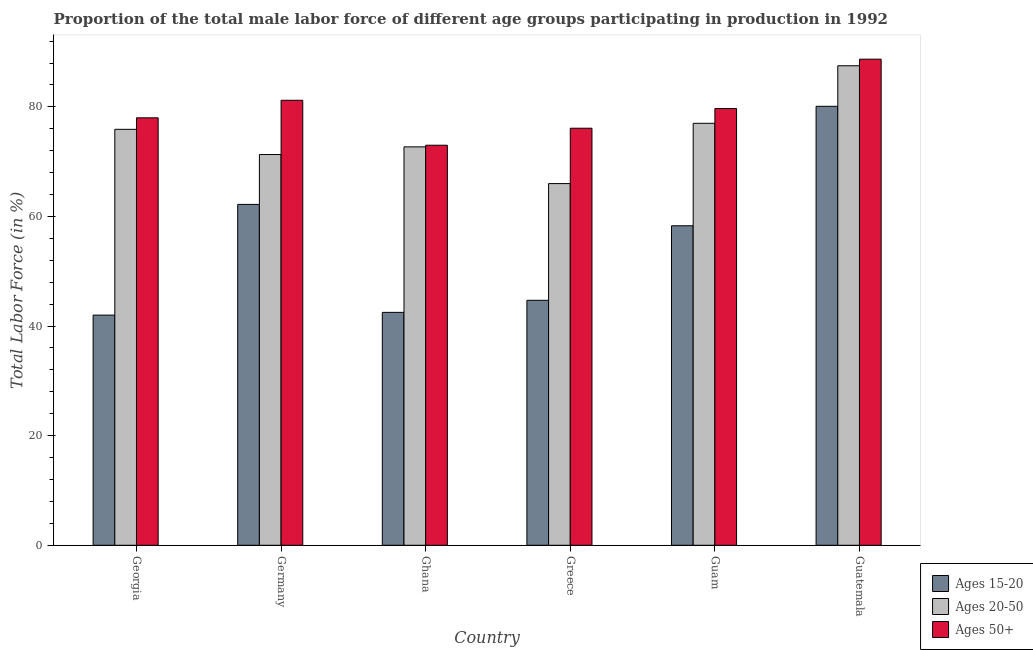How many different coloured bars are there?
Provide a succinct answer. 3. How many groups of bars are there?
Keep it short and to the point. 6. Are the number of bars per tick equal to the number of legend labels?
Provide a succinct answer. Yes. How many bars are there on the 4th tick from the left?
Offer a very short reply. 3. How many bars are there on the 6th tick from the right?
Provide a short and direct response. 3. In how many cases, is the number of bars for a given country not equal to the number of legend labels?
Provide a succinct answer. 0. What is the percentage of male labor force within the age group 15-20 in Guatemala?
Ensure brevity in your answer.  80.1. Across all countries, what is the maximum percentage of male labor force within the age group 20-50?
Your answer should be very brief. 87.5. In which country was the percentage of male labor force within the age group 15-20 maximum?
Provide a short and direct response. Guatemala. In which country was the percentage of male labor force above age 50 minimum?
Offer a terse response. Ghana. What is the total percentage of male labor force above age 50 in the graph?
Your response must be concise. 476.7. What is the difference between the percentage of male labor force within the age group 20-50 in Germany and that in Greece?
Make the answer very short. 5.3. What is the difference between the percentage of male labor force within the age group 20-50 in Greece and the percentage of male labor force above age 50 in Guam?
Offer a very short reply. -13.7. What is the average percentage of male labor force above age 50 per country?
Keep it short and to the point. 79.45. What is the difference between the percentage of male labor force above age 50 and percentage of male labor force within the age group 15-20 in Guatemala?
Offer a terse response. 8.6. What is the ratio of the percentage of male labor force above age 50 in Ghana to that in Guam?
Your answer should be compact. 0.92. Is the percentage of male labor force within the age group 20-50 in Ghana less than that in Guam?
Offer a very short reply. Yes. What is the difference between the highest and the second highest percentage of male labor force within the age group 15-20?
Provide a short and direct response. 17.9. In how many countries, is the percentage of male labor force within the age group 20-50 greater than the average percentage of male labor force within the age group 20-50 taken over all countries?
Your answer should be very brief. 3. Is the sum of the percentage of male labor force within the age group 15-20 in Germany and Greece greater than the maximum percentage of male labor force within the age group 20-50 across all countries?
Offer a very short reply. Yes. What does the 1st bar from the left in Ghana represents?
Your answer should be very brief. Ages 15-20. What does the 3rd bar from the right in Guatemala represents?
Offer a very short reply. Ages 15-20. How many bars are there?
Keep it short and to the point. 18. Are all the bars in the graph horizontal?
Your answer should be compact. No. Are the values on the major ticks of Y-axis written in scientific E-notation?
Keep it short and to the point. No. Does the graph contain any zero values?
Offer a very short reply. No. Does the graph contain grids?
Offer a terse response. No. Where does the legend appear in the graph?
Your answer should be very brief. Bottom right. How many legend labels are there?
Provide a succinct answer. 3. How are the legend labels stacked?
Provide a succinct answer. Vertical. What is the title of the graph?
Offer a very short reply. Proportion of the total male labor force of different age groups participating in production in 1992. What is the Total Labor Force (in %) of Ages 20-50 in Georgia?
Give a very brief answer. 75.9. What is the Total Labor Force (in %) in Ages 15-20 in Germany?
Provide a short and direct response. 62.2. What is the Total Labor Force (in %) of Ages 20-50 in Germany?
Provide a short and direct response. 71.3. What is the Total Labor Force (in %) in Ages 50+ in Germany?
Provide a succinct answer. 81.2. What is the Total Labor Force (in %) of Ages 15-20 in Ghana?
Provide a succinct answer. 42.5. What is the Total Labor Force (in %) in Ages 20-50 in Ghana?
Provide a succinct answer. 72.7. What is the Total Labor Force (in %) of Ages 15-20 in Greece?
Offer a terse response. 44.7. What is the Total Labor Force (in %) in Ages 20-50 in Greece?
Offer a terse response. 66. What is the Total Labor Force (in %) in Ages 50+ in Greece?
Offer a terse response. 76.1. What is the Total Labor Force (in %) of Ages 15-20 in Guam?
Your answer should be very brief. 58.3. What is the Total Labor Force (in %) of Ages 20-50 in Guam?
Ensure brevity in your answer.  77. What is the Total Labor Force (in %) in Ages 50+ in Guam?
Ensure brevity in your answer.  79.7. What is the Total Labor Force (in %) in Ages 15-20 in Guatemala?
Ensure brevity in your answer.  80.1. What is the Total Labor Force (in %) of Ages 20-50 in Guatemala?
Give a very brief answer. 87.5. What is the Total Labor Force (in %) in Ages 50+ in Guatemala?
Your answer should be compact. 88.7. Across all countries, what is the maximum Total Labor Force (in %) of Ages 15-20?
Ensure brevity in your answer.  80.1. Across all countries, what is the maximum Total Labor Force (in %) of Ages 20-50?
Your answer should be very brief. 87.5. Across all countries, what is the maximum Total Labor Force (in %) of Ages 50+?
Provide a succinct answer. 88.7. Across all countries, what is the minimum Total Labor Force (in %) in Ages 20-50?
Ensure brevity in your answer.  66. What is the total Total Labor Force (in %) in Ages 15-20 in the graph?
Your response must be concise. 329.8. What is the total Total Labor Force (in %) of Ages 20-50 in the graph?
Ensure brevity in your answer.  450.4. What is the total Total Labor Force (in %) in Ages 50+ in the graph?
Make the answer very short. 476.7. What is the difference between the Total Labor Force (in %) in Ages 15-20 in Georgia and that in Germany?
Offer a very short reply. -20.2. What is the difference between the Total Labor Force (in %) in Ages 20-50 in Georgia and that in Germany?
Give a very brief answer. 4.6. What is the difference between the Total Labor Force (in %) in Ages 50+ in Georgia and that in Germany?
Offer a terse response. -3.2. What is the difference between the Total Labor Force (in %) in Ages 15-20 in Georgia and that in Ghana?
Offer a terse response. -0.5. What is the difference between the Total Labor Force (in %) in Ages 15-20 in Georgia and that in Guam?
Provide a succinct answer. -16.3. What is the difference between the Total Labor Force (in %) of Ages 20-50 in Georgia and that in Guam?
Give a very brief answer. -1.1. What is the difference between the Total Labor Force (in %) of Ages 50+ in Georgia and that in Guam?
Provide a short and direct response. -1.7. What is the difference between the Total Labor Force (in %) of Ages 15-20 in Georgia and that in Guatemala?
Your answer should be very brief. -38.1. What is the difference between the Total Labor Force (in %) of Ages 20-50 in Georgia and that in Guatemala?
Offer a very short reply. -11.6. What is the difference between the Total Labor Force (in %) of Ages 50+ in Georgia and that in Guatemala?
Your answer should be very brief. -10.7. What is the difference between the Total Labor Force (in %) of Ages 15-20 in Germany and that in Ghana?
Offer a very short reply. 19.7. What is the difference between the Total Labor Force (in %) of Ages 20-50 in Germany and that in Ghana?
Your answer should be very brief. -1.4. What is the difference between the Total Labor Force (in %) in Ages 50+ in Germany and that in Ghana?
Ensure brevity in your answer.  8.2. What is the difference between the Total Labor Force (in %) in Ages 15-20 in Germany and that in Greece?
Your response must be concise. 17.5. What is the difference between the Total Labor Force (in %) of Ages 50+ in Germany and that in Greece?
Offer a terse response. 5.1. What is the difference between the Total Labor Force (in %) in Ages 15-20 in Germany and that in Guam?
Keep it short and to the point. 3.9. What is the difference between the Total Labor Force (in %) of Ages 50+ in Germany and that in Guam?
Provide a short and direct response. 1.5. What is the difference between the Total Labor Force (in %) in Ages 15-20 in Germany and that in Guatemala?
Give a very brief answer. -17.9. What is the difference between the Total Labor Force (in %) in Ages 20-50 in Germany and that in Guatemala?
Your answer should be compact. -16.2. What is the difference between the Total Labor Force (in %) in Ages 50+ in Germany and that in Guatemala?
Offer a very short reply. -7.5. What is the difference between the Total Labor Force (in %) of Ages 20-50 in Ghana and that in Greece?
Provide a short and direct response. 6.7. What is the difference between the Total Labor Force (in %) of Ages 15-20 in Ghana and that in Guam?
Give a very brief answer. -15.8. What is the difference between the Total Labor Force (in %) in Ages 15-20 in Ghana and that in Guatemala?
Make the answer very short. -37.6. What is the difference between the Total Labor Force (in %) in Ages 20-50 in Ghana and that in Guatemala?
Make the answer very short. -14.8. What is the difference between the Total Labor Force (in %) of Ages 50+ in Ghana and that in Guatemala?
Ensure brevity in your answer.  -15.7. What is the difference between the Total Labor Force (in %) in Ages 20-50 in Greece and that in Guam?
Your answer should be compact. -11. What is the difference between the Total Labor Force (in %) in Ages 15-20 in Greece and that in Guatemala?
Provide a succinct answer. -35.4. What is the difference between the Total Labor Force (in %) in Ages 20-50 in Greece and that in Guatemala?
Make the answer very short. -21.5. What is the difference between the Total Labor Force (in %) of Ages 15-20 in Guam and that in Guatemala?
Ensure brevity in your answer.  -21.8. What is the difference between the Total Labor Force (in %) of Ages 50+ in Guam and that in Guatemala?
Your answer should be compact. -9. What is the difference between the Total Labor Force (in %) in Ages 15-20 in Georgia and the Total Labor Force (in %) in Ages 20-50 in Germany?
Give a very brief answer. -29.3. What is the difference between the Total Labor Force (in %) in Ages 15-20 in Georgia and the Total Labor Force (in %) in Ages 50+ in Germany?
Provide a succinct answer. -39.2. What is the difference between the Total Labor Force (in %) in Ages 20-50 in Georgia and the Total Labor Force (in %) in Ages 50+ in Germany?
Give a very brief answer. -5.3. What is the difference between the Total Labor Force (in %) in Ages 15-20 in Georgia and the Total Labor Force (in %) in Ages 20-50 in Ghana?
Give a very brief answer. -30.7. What is the difference between the Total Labor Force (in %) of Ages 15-20 in Georgia and the Total Labor Force (in %) of Ages 50+ in Ghana?
Ensure brevity in your answer.  -31. What is the difference between the Total Labor Force (in %) in Ages 20-50 in Georgia and the Total Labor Force (in %) in Ages 50+ in Ghana?
Provide a succinct answer. 2.9. What is the difference between the Total Labor Force (in %) of Ages 15-20 in Georgia and the Total Labor Force (in %) of Ages 50+ in Greece?
Offer a terse response. -34.1. What is the difference between the Total Labor Force (in %) in Ages 15-20 in Georgia and the Total Labor Force (in %) in Ages 20-50 in Guam?
Give a very brief answer. -35. What is the difference between the Total Labor Force (in %) in Ages 15-20 in Georgia and the Total Labor Force (in %) in Ages 50+ in Guam?
Make the answer very short. -37.7. What is the difference between the Total Labor Force (in %) of Ages 15-20 in Georgia and the Total Labor Force (in %) of Ages 20-50 in Guatemala?
Your response must be concise. -45.5. What is the difference between the Total Labor Force (in %) of Ages 15-20 in Georgia and the Total Labor Force (in %) of Ages 50+ in Guatemala?
Keep it short and to the point. -46.7. What is the difference between the Total Labor Force (in %) in Ages 20-50 in Germany and the Total Labor Force (in %) in Ages 50+ in Ghana?
Ensure brevity in your answer.  -1.7. What is the difference between the Total Labor Force (in %) of Ages 20-50 in Germany and the Total Labor Force (in %) of Ages 50+ in Greece?
Ensure brevity in your answer.  -4.8. What is the difference between the Total Labor Force (in %) in Ages 15-20 in Germany and the Total Labor Force (in %) in Ages 20-50 in Guam?
Give a very brief answer. -14.8. What is the difference between the Total Labor Force (in %) in Ages 15-20 in Germany and the Total Labor Force (in %) in Ages 50+ in Guam?
Offer a terse response. -17.5. What is the difference between the Total Labor Force (in %) of Ages 15-20 in Germany and the Total Labor Force (in %) of Ages 20-50 in Guatemala?
Your answer should be compact. -25.3. What is the difference between the Total Labor Force (in %) of Ages 15-20 in Germany and the Total Labor Force (in %) of Ages 50+ in Guatemala?
Make the answer very short. -26.5. What is the difference between the Total Labor Force (in %) of Ages 20-50 in Germany and the Total Labor Force (in %) of Ages 50+ in Guatemala?
Keep it short and to the point. -17.4. What is the difference between the Total Labor Force (in %) in Ages 15-20 in Ghana and the Total Labor Force (in %) in Ages 20-50 in Greece?
Provide a short and direct response. -23.5. What is the difference between the Total Labor Force (in %) of Ages 15-20 in Ghana and the Total Labor Force (in %) of Ages 50+ in Greece?
Offer a terse response. -33.6. What is the difference between the Total Labor Force (in %) of Ages 15-20 in Ghana and the Total Labor Force (in %) of Ages 20-50 in Guam?
Ensure brevity in your answer.  -34.5. What is the difference between the Total Labor Force (in %) of Ages 15-20 in Ghana and the Total Labor Force (in %) of Ages 50+ in Guam?
Make the answer very short. -37.2. What is the difference between the Total Labor Force (in %) of Ages 15-20 in Ghana and the Total Labor Force (in %) of Ages 20-50 in Guatemala?
Provide a succinct answer. -45. What is the difference between the Total Labor Force (in %) in Ages 15-20 in Ghana and the Total Labor Force (in %) in Ages 50+ in Guatemala?
Provide a succinct answer. -46.2. What is the difference between the Total Labor Force (in %) of Ages 15-20 in Greece and the Total Labor Force (in %) of Ages 20-50 in Guam?
Provide a short and direct response. -32.3. What is the difference between the Total Labor Force (in %) of Ages 15-20 in Greece and the Total Labor Force (in %) of Ages 50+ in Guam?
Make the answer very short. -35. What is the difference between the Total Labor Force (in %) in Ages 20-50 in Greece and the Total Labor Force (in %) in Ages 50+ in Guam?
Ensure brevity in your answer.  -13.7. What is the difference between the Total Labor Force (in %) in Ages 15-20 in Greece and the Total Labor Force (in %) in Ages 20-50 in Guatemala?
Keep it short and to the point. -42.8. What is the difference between the Total Labor Force (in %) in Ages 15-20 in Greece and the Total Labor Force (in %) in Ages 50+ in Guatemala?
Provide a succinct answer. -44. What is the difference between the Total Labor Force (in %) of Ages 20-50 in Greece and the Total Labor Force (in %) of Ages 50+ in Guatemala?
Keep it short and to the point. -22.7. What is the difference between the Total Labor Force (in %) in Ages 15-20 in Guam and the Total Labor Force (in %) in Ages 20-50 in Guatemala?
Provide a short and direct response. -29.2. What is the difference between the Total Labor Force (in %) in Ages 15-20 in Guam and the Total Labor Force (in %) in Ages 50+ in Guatemala?
Ensure brevity in your answer.  -30.4. What is the average Total Labor Force (in %) in Ages 15-20 per country?
Ensure brevity in your answer.  54.97. What is the average Total Labor Force (in %) of Ages 20-50 per country?
Keep it short and to the point. 75.07. What is the average Total Labor Force (in %) in Ages 50+ per country?
Ensure brevity in your answer.  79.45. What is the difference between the Total Labor Force (in %) of Ages 15-20 and Total Labor Force (in %) of Ages 20-50 in Georgia?
Offer a terse response. -33.9. What is the difference between the Total Labor Force (in %) in Ages 15-20 and Total Labor Force (in %) in Ages 50+ in Georgia?
Provide a succinct answer. -36. What is the difference between the Total Labor Force (in %) in Ages 20-50 and Total Labor Force (in %) in Ages 50+ in Georgia?
Your answer should be compact. -2.1. What is the difference between the Total Labor Force (in %) of Ages 15-20 and Total Labor Force (in %) of Ages 20-50 in Germany?
Offer a very short reply. -9.1. What is the difference between the Total Labor Force (in %) of Ages 15-20 and Total Labor Force (in %) of Ages 50+ in Germany?
Ensure brevity in your answer.  -19. What is the difference between the Total Labor Force (in %) in Ages 15-20 and Total Labor Force (in %) in Ages 20-50 in Ghana?
Provide a short and direct response. -30.2. What is the difference between the Total Labor Force (in %) of Ages 15-20 and Total Labor Force (in %) of Ages 50+ in Ghana?
Give a very brief answer. -30.5. What is the difference between the Total Labor Force (in %) in Ages 15-20 and Total Labor Force (in %) in Ages 20-50 in Greece?
Keep it short and to the point. -21.3. What is the difference between the Total Labor Force (in %) in Ages 15-20 and Total Labor Force (in %) in Ages 50+ in Greece?
Provide a short and direct response. -31.4. What is the difference between the Total Labor Force (in %) of Ages 20-50 and Total Labor Force (in %) of Ages 50+ in Greece?
Your answer should be very brief. -10.1. What is the difference between the Total Labor Force (in %) of Ages 15-20 and Total Labor Force (in %) of Ages 20-50 in Guam?
Make the answer very short. -18.7. What is the difference between the Total Labor Force (in %) in Ages 15-20 and Total Labor Force (in %) in Ages 50+ in Guam?
Keep it short and to the point. -21.4. What is the difference between the Total Labor Force (in %) in Ages 15-20 and Total Labor Force (in %) in Ages 20-50 in Guatemala?
Keep it short and to the point. -7.4. What is the difference between the Total Labor Force (in %) in Ages 20-50 and Total Labor Force (in %) in Ages 50+ in Guatemala?
Your answer should be compact. -1.2. What is the ratio of the Total Labor Force (in %) of Ages 15-20 in Georgia to that in Germany?
Your response must be concise. 0.68. What is the ratio of the Total Labor Force (in %) in Ages 20-50 in Georgia to that in Germany?
Offer a terse response. 1.06. What is the ratio of the Total Labor Force (in %) of Ages 50+ in Georgia to that in Germany?
Ensure brevity in your answer.  0.96. What is the ratio of the Total Labor Force (in %) of Ages 15-20 in Georgia to that in Ghana?
Your response must be concise. 0.99. What is the ratio of the Total Labor Force (in %) of Ages 20-50 in Georgia to that in Ghana?
Your answer should be very brief. 1.04. What is the ratio of the Total Labor Force (in %) of Ages 50+ in Georgia to that in Ghana?
Ensure brevity in your answer.  1.07. What is the ratio of the Total Labor Force (in %) of Ages 15-20 in Georgia to that in Greece?
Provide a short and direct response. 0.94. What is the ratio of the Total Labor Force (in %) of Ages 20-50 in Georgia to that in Greece?
Your answer should be very brief. 1.15. What is the ratio of the Total Labor Force (in %) of Ages 50+ in Georgia to that in Greece?
Your response must be concise. 1.02. What is the ratio of the Total Labor Force (in %) of Ages 15-20 in Georgia to that in Guam?
Provide a short and direct response. 0.72. What is the ratio of the Total Labor Force (in %) in Ages 20-50 in Georgia to that in Guam?
Ensure brevity in your answer.  0.99. What is the ratio of the Total Labor Force (in %) in Ages 50+ in Georgia to that in Guam?
Provide a succinct answer. 0.98. What is the ratio of the Total Labor Force (in %) in Ages 15-20 in Georgia to that in Guatemala?
Keep it short and to the point. 0.52. What is the ratio of the Total Labor Force (in %) of Ages 20-50 in Georgia to that in Guatemala?
Ensure brevity in your answer.  0.87. What is the ratio of the Total Labor Force (in %) in Ages 50+ in Georgia to that in Guatemala?
Your answer should be compact. 0.88. What is the ratio of the Total Labor Force (in %) of Ages 15-20 in Germany to that in Ghana?
Keep it short and to the point. 1.46. What is the ratio of the Total Labor Force (in %) of Ages 20-50 in Germany to that in Ghana?
Provide a short and direct response. 0.98. What is the ratio of the Total Labor Force (in %) of Ages 50+ in Germany to that in Ghana?
Give a very brief answer. 1.11. What is the ratio of the Total Labor Force (in %) in Ages 15-20 in Germany to that in Greece?
Offer a very short reply. 1.39. What is the ratio of the Total Labor Force (in %) of Ages 20-50 in Germany to that in Greece?
Your answer should be compact. 1.08. What is the ratio of the Total Labor Force (in %) in Ages 50+ in Germany to that in Greece?
Your response must be concise. 1.07. What is the ratio of the Total Labor Force (in %) of Ages 15-20 in Germany to that in Guam?
Your answer should be compact. 1.07. What is the ratio of the Total Labor Force (in %) of Ages 20-50 in Germany to that in Guam?
Your answer should be compact. 0.93. What is the ratio of the Total Labor Force (in %) in Ages 50+ in Germany to that in Guam?
Provide a succinct answer. 1.02. What is the ratio of the Total Labor Force (in %) of Ages 15-20 in Germany to that in Guatemala?
Provide a short and direct response. 0.78. What is the ratio of the Total Labor Force (in %) of Ages 20-50 in Germany to that in Guatemala?
Your answer should be compact. 0.81. What is the ratio of the Total Labor Force (in %) of Ages 50+ in Germany to that in Guatemala?
Provide a succinct answer. 0.92. What is the ratio of the Total Labor Force (in %) in Ages 15-20 in Ghana to that in Greece?
Provide a short and direct response. 0.95. What is the ratio of the Total Labor Force (in %) in Ages 20-50 in Ghana to that in Greece?
Provide a short and direct response. 1.1. What is the ratio of the Total Labor Force (in %) of Ages 50+ in Ghana to that in Greece?
Your answer should be compact. 0.96. What is the ratio of the Total Labor Force (in %) of Ages 15-20 in Ghana to that in Guam?
Your answer should be very brief. 0.73. What is the ratio of the Total Labor Force (in %) in Ages 20-50 in Ghana to that in Guam?
Offer a very short reply. 0.94. What is the ratio of the Total Labor Force (in %) in Ages 50+ in Ghana to that in Guam?
Keep it short and to the point. 0.92. What is the ratio of the Total Labor Force (in %) in Ages 15-20 in Ghana to that in Guatemala?
Your answer should be very brief. 0.53. What is the ratio of the Total Labor Force (in %) of Ages 20-50 in Ghana to that in Guatemala?
Your answer should be compact. 0.83. What is the ratio of the Total Labor Force (in %) in Ages 50+ in Ghana to that in Guatemala?
Keep it short and to the point. 0.82. What is the ratio of the Total Labor Force (in %) in Ages 15-20 in Greece to that in Guam?
Make the answer very short. 0.77. What is the ratio of the Total Labor Force (in %) of Ages 50+ in Greece to that in Guam?
Make the answer very short. 0.95. What is the ratio of the Total Labor Force (in %) of Ages 15-20 in Greece to that in Guatemala?
Provide a short and direct response. 0.56. What is the ratio of the Total Labor Force (in %) in Ages 20-50 in Greece to that in Guatemala?
Your answer should be very brief. 0.75. What is the ratio of the Total Labor Force (in %) of Ages 50+ in Greece to that in Guatemala?
Keep it short and to the point. 0.86. What is the ratio of the Total Labor Force (in %) in Ages 15-20 in Guam to that in Guatemala?
Your answer should be compact. 0.73. What is the ratio of the Total Labor Force (in %) of Ages 20-50 in Guam to that in Guatemala?
Offer a terse response. 0.88. What is the ratio of the Total Labor Force (in %) of Ages 50+ in Guam to that in Guatemala?
Make the answer very short. 0.9. What is the difference between the highest and the second highest Total Labor Force (in %) in Ages 20-50?
Provide a short and direct response. 10.5. What is the difference between the highest and the second highest Total Labor Force (in %) of Ages 50+?
Keep it short and to the point. 7.5. What is the difference between the highest and the lowest Total Labor Force (in %) of Ages 15-20?
Provide a short and direct response. 38.1. 